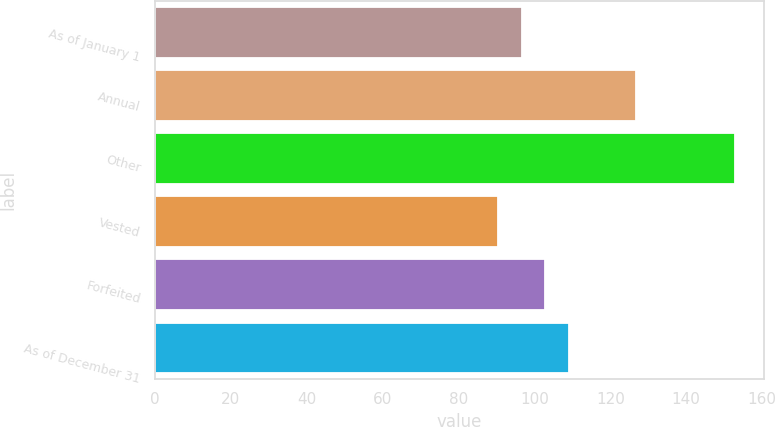Convert chart. <chart><loc_0><loc_0><loc_500><loc_500><bar_chart><fcel>As of January 1<fcel>Annual<fcel>Other<fcel>Vested<fcel>Forfeited<fcel>As of December 31<nl><fcel>96.61<fcel>126.79<fcel>152.74<fcel>90.37<fcel>102.85<fcel>109.09<nl></chart> 